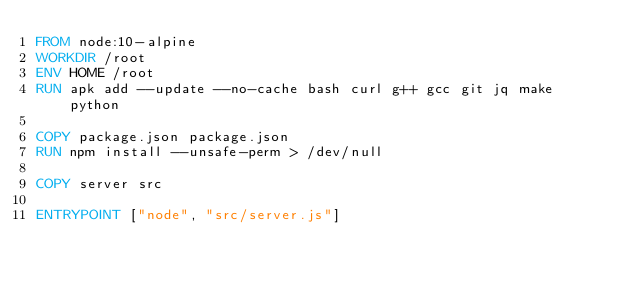Convert code to text. <code><loc_0><loc_0><loc_500><loc_500><_Dockerfile_>FROM node:10-alpine
WORKDIR /root
ENV HOME /root
RUN apk add --update --no-cache bash curl g++ gcc git jq make python

COPY package.json package.json
RUN npm install --unsafe-perm > /dev/null

COPY server src

ENTRYPOINT ["node", "src/server.js"]
</code> 